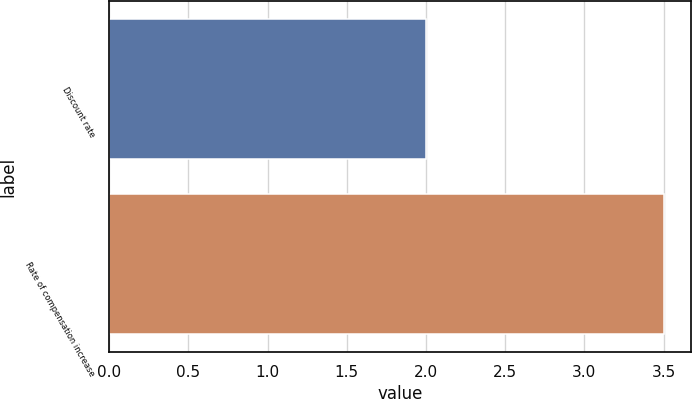Convert chart. <chart><loc_0><loc_0><loc_500><loc_500><bar_chart><fcel>Discount rate<fcel>Rate of compensation increase<nl><fcel>2<fcel>3.5<nl></chart> 